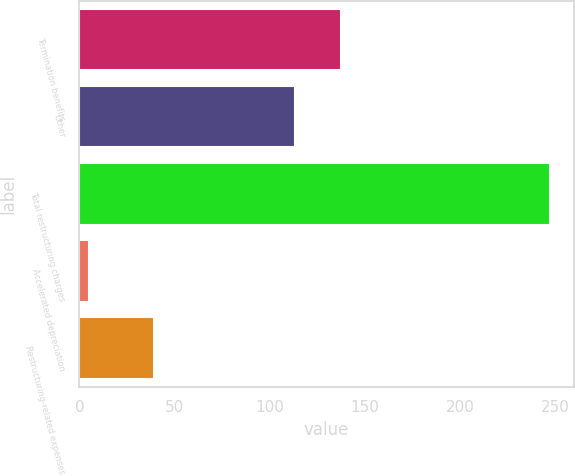Convert chart. <chart><loc_0><loc_0><loc_500><loc_500><bar_chart><fcel>Termination benefits<fcel>Other<fcel>Total restructuring charges<fcel>Accelerated depreciation<fcel>Restructuring-related expenses<nl><fcel>137.2<fcel>113<fcel>247<fcel>5<fcel>39<nl></chart> 